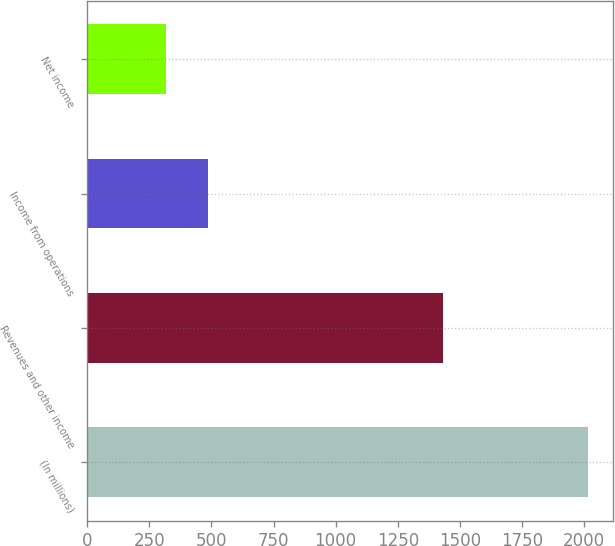<chart> <loc_0><loc_0><loc_500><loc_500><bar_chart><fcel>(In millions)<fcel>Revenues and other income<fcel>Income from operations<fcel>Net income<nl><fcel>2014<fcel>1430<fcel>485.8<fcel>316<nl></chart> 